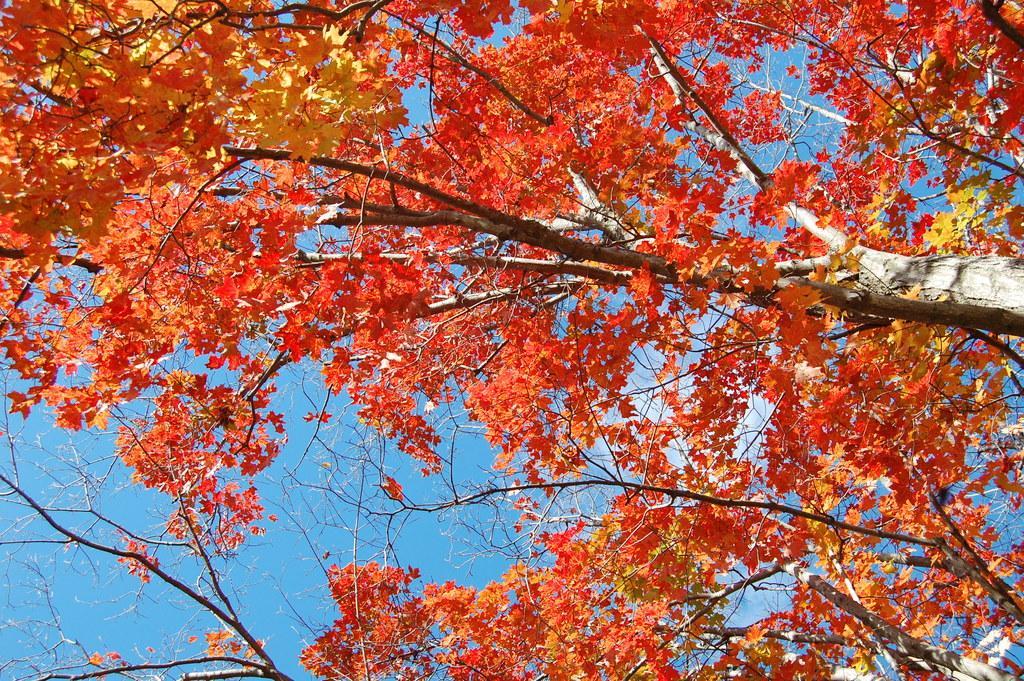How would you summarize this image in a sentence or two? In the picture I can see trees. The leaves of trees are red and yellow in color. In the background I can see the sky. 